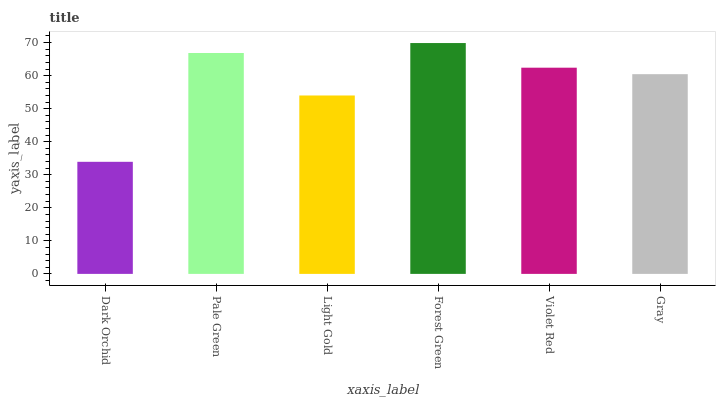Is Pale Green the minimum?
Answer yes or no. No. Is Pale Green the maximum?
Answer yes or no. No. Is Pale Green greater than Dark Orchid?
Answer yes or no. Yes. Is Dark Orchid less than Pale Green?
Answer yes or no. Yes. Is Dark Orchid greater than Pale Green?
Answer yes or no. No. Is Pale Green less than Dark Orchid?
Answer yes or no. No. Is Violet Red the high median?
Answer yes or no. Yes. Is Gray the low median?
Answer yes or no. Yes. Is Gray the high median?
Answer yes or no. No. Is Light Gold the low median?
Answer yes or no. No. 